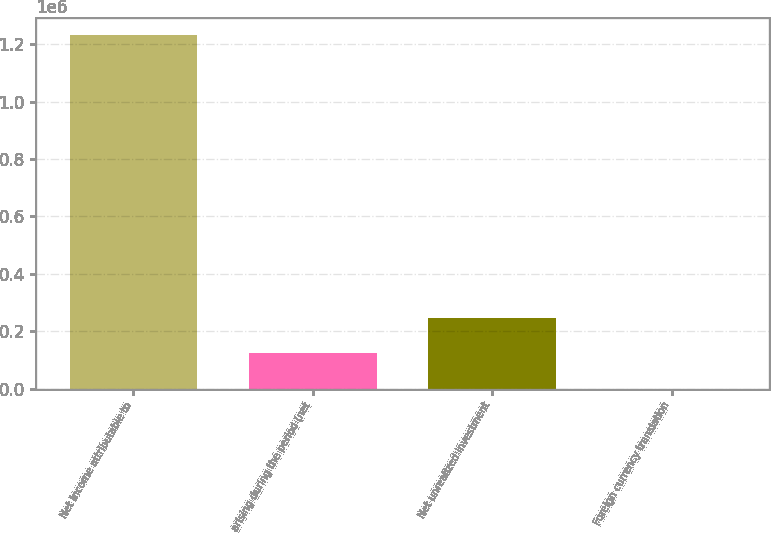Convert chart to OTSL. <chart><loc_0><loc_0><loc_500><loc_500><bar_chart><fcel>Net income attributable to<fcel>arising during the period (net<fcel>Net unrealized investment<fcel>Foreign currency translation<nl><fcel>1.23109e+06<fcel>123520<fcel>246584<fcel>457<nl></chart> 